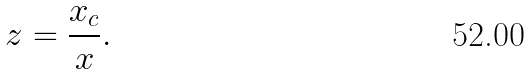<formula> <loc_0><loc_0><loc_500><loc_500>z = \frac { x _ { c } } { x } .</formula> 